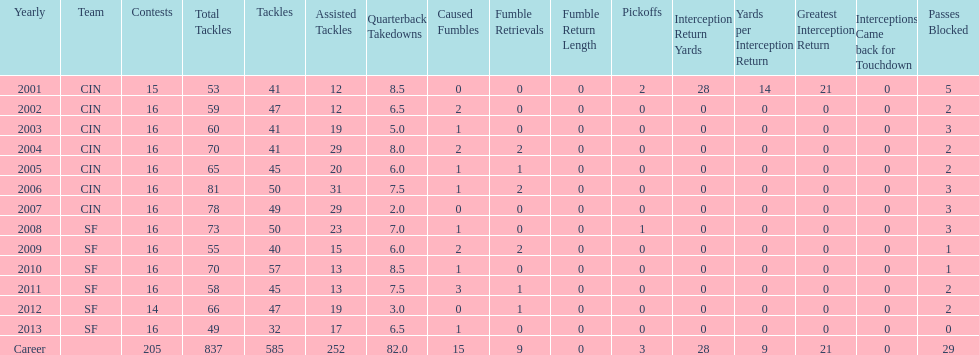What is the total number of sacks smith has made? 82.0. 